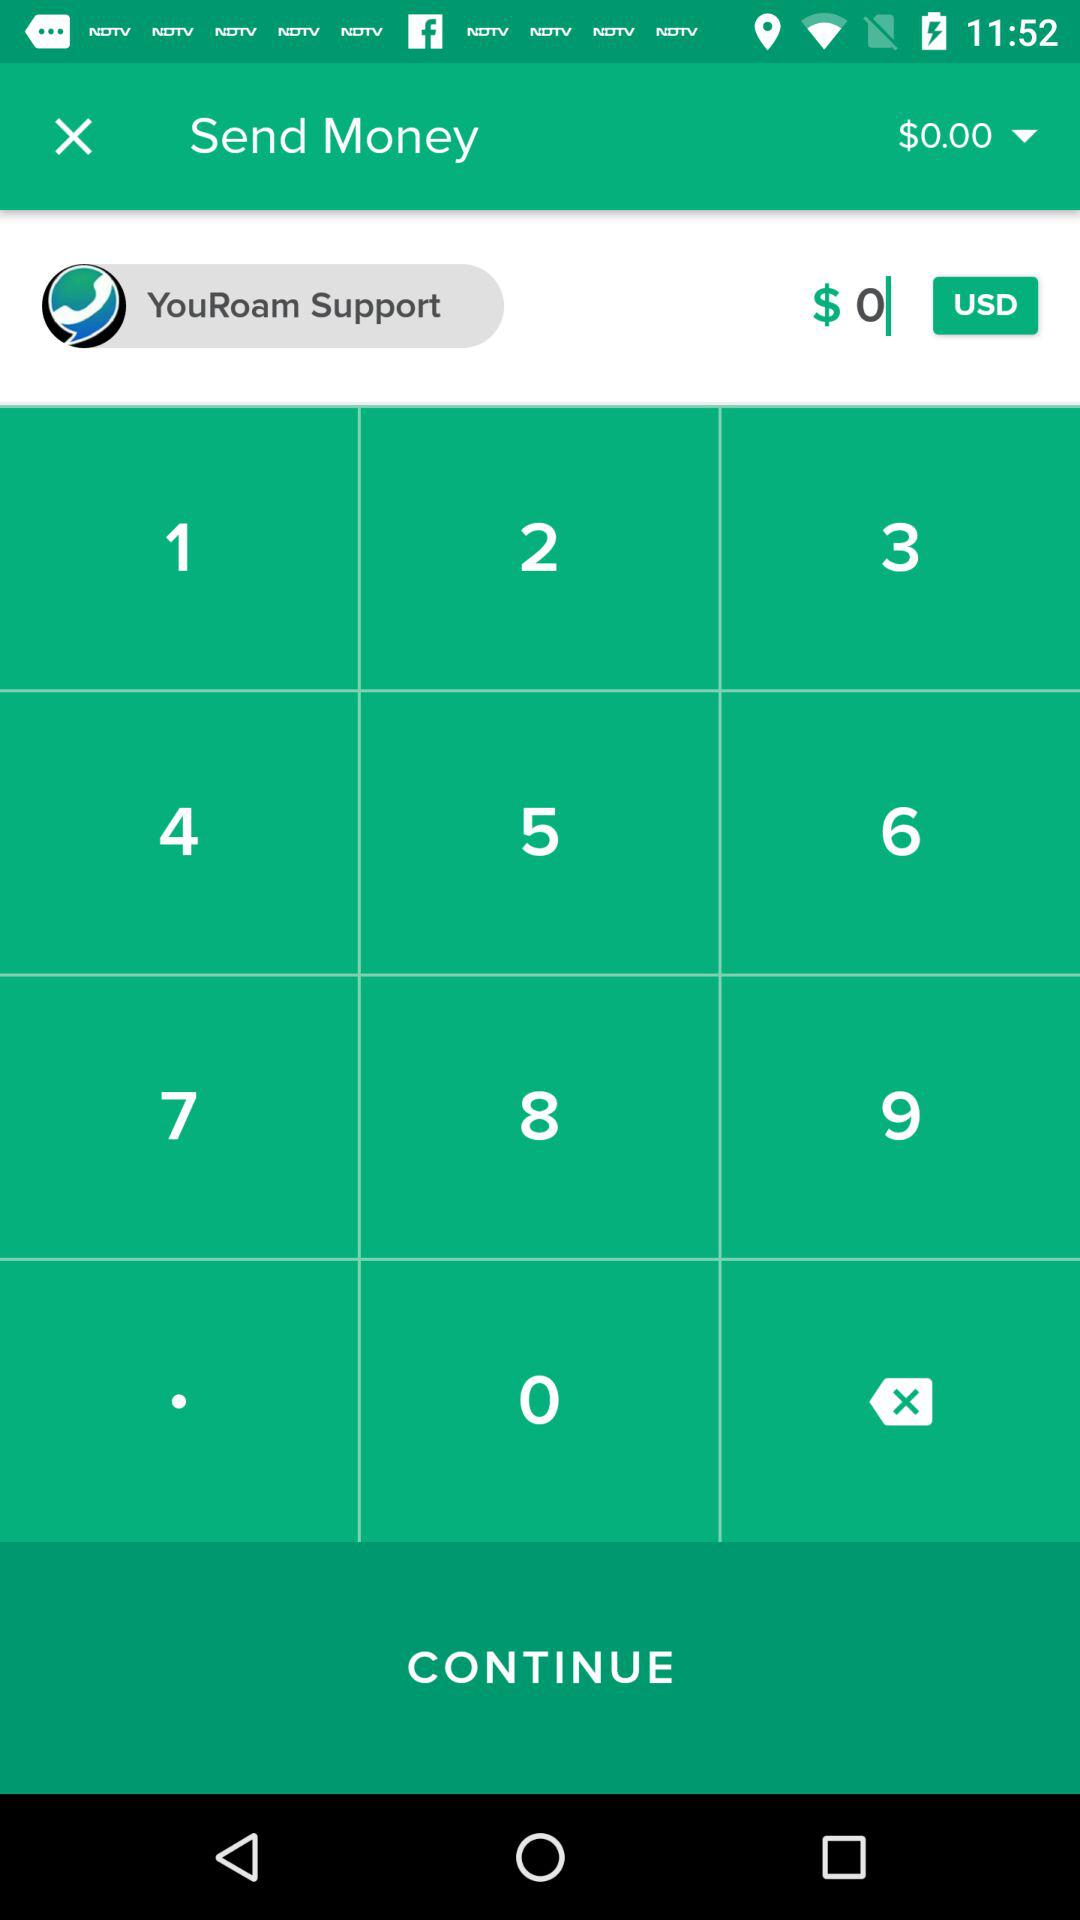What is the customer service support number?
When the provided information is insufficient, respond with <no answer>. <no answer> 